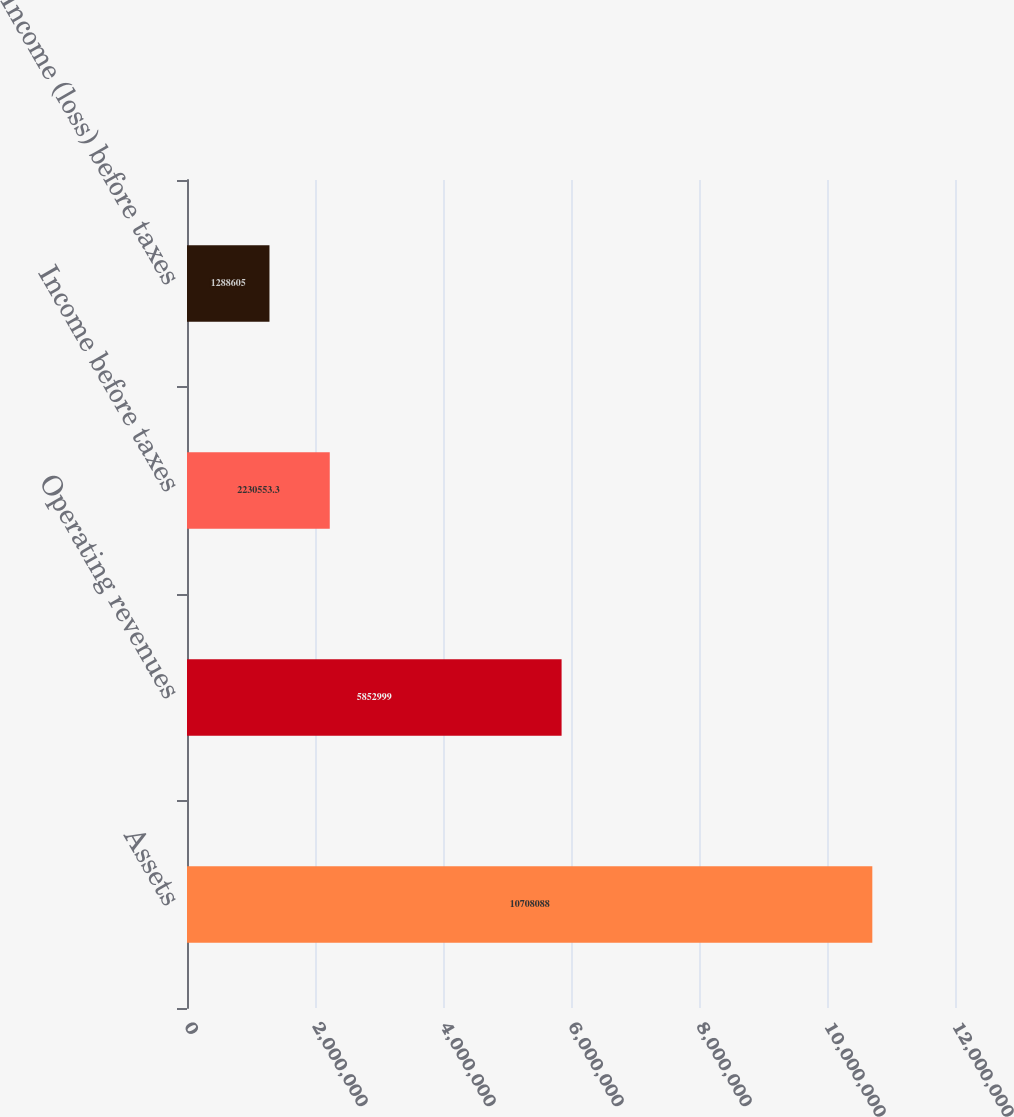Convert chart. <chart><loc_0><loc_0><loc_500><loc_500><bar_chart><fcel>Assets<fcel>Operating revenues<fcel>Income before taxes<fcel>Income (loss) before taxes<nl><fcel>1.07081e+07<fcel>5.853e+06<fcel>2.23055e+06<fcel>1.2886e+06<nl></chart> 